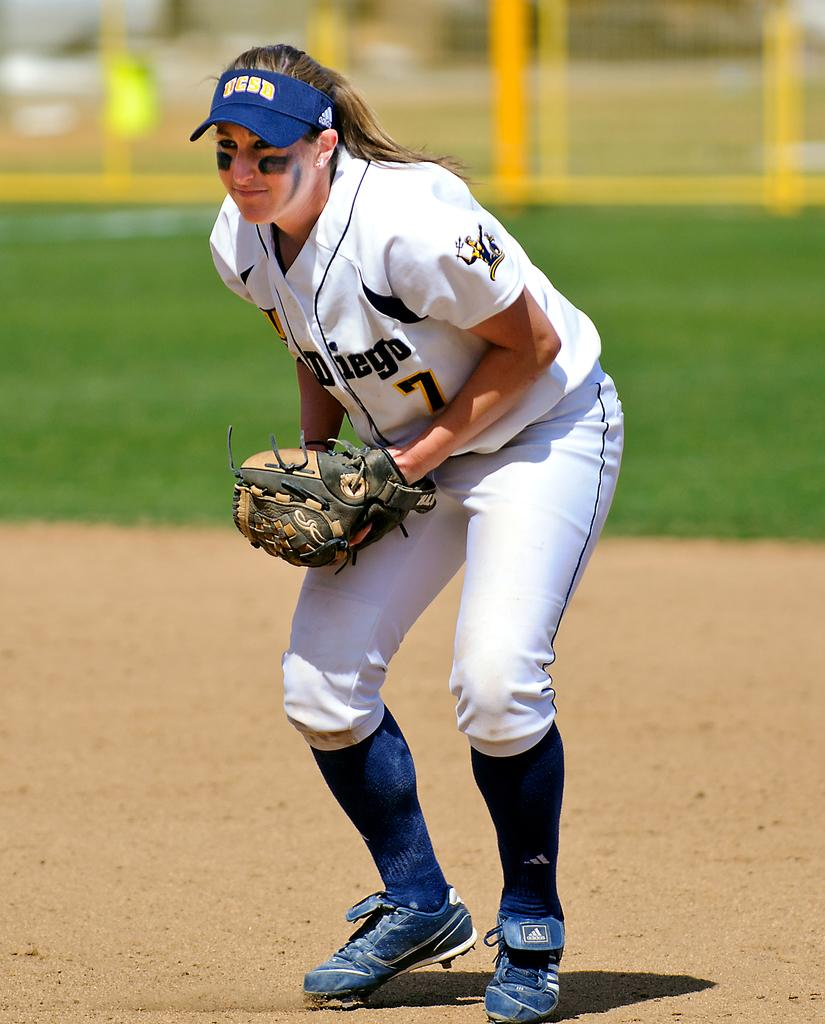<image>
Summarize the visual content of the image. A player for the UC San Diego woman's baseball team is on the field 